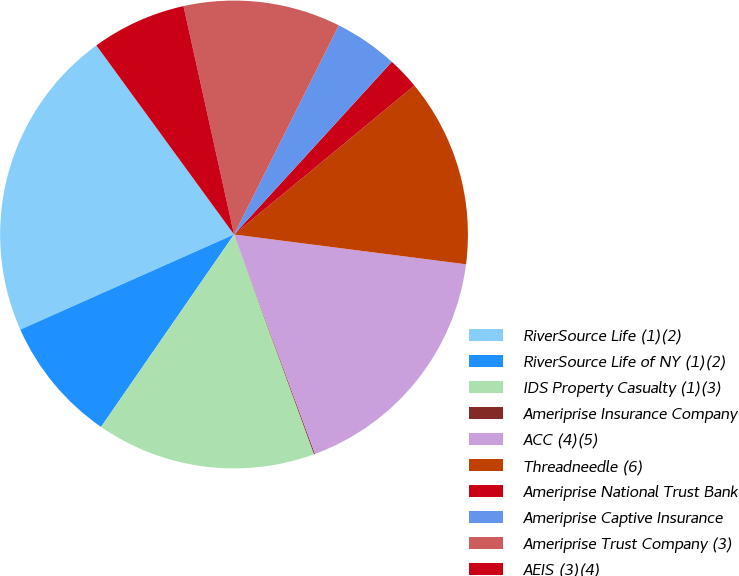Convert chart. <chart><loc_0><loc_0><loc_500><loc_500><pie_chart><fcel>RiverSource Life (1)(2)<fcel>RiverSource Life of NY (1)(2)<fcel>IDS Property Casualty (1)(3)<fcel>Ameriprise Insurance Company<fcel>ACC (4)(5)<fcel>Threadneedle (6)<fcel>Ameriprise National Trust Bank<fcel>Ameriprise Captive Insurance<fcel>Ameriprise Trust Company (3)<fcel>AEIS (3)(4)<nl><fcel>21.65%<fcel>8.71%<fcel>15.18%<fcel>0.07%<fcel>17.34%<fcel>13.02%<fcel>2.23%<fcel>4.39%<fcel>10.86%<fcel>6.55%<nl></chart> 